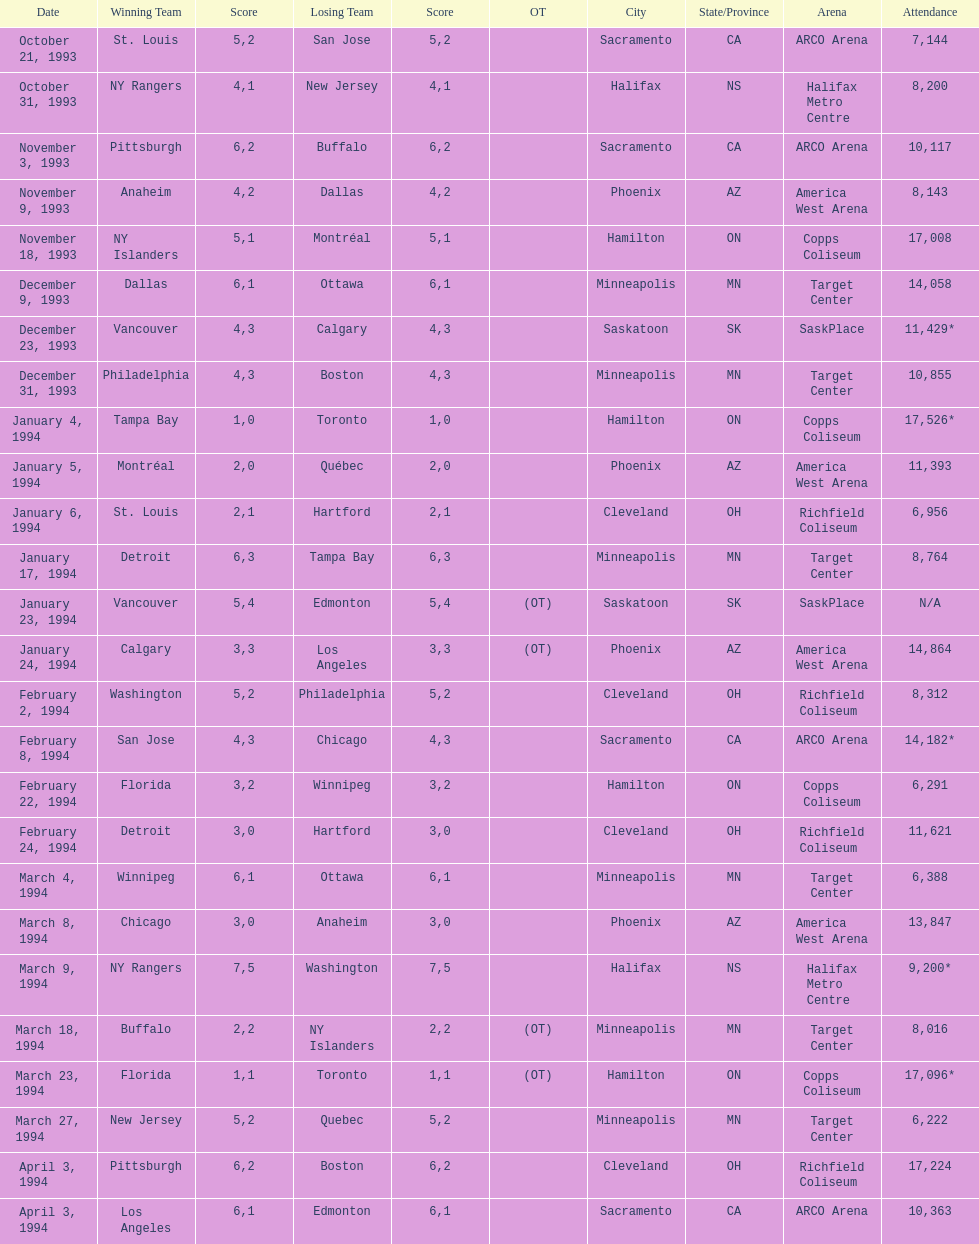Would you be able to parse every entry in this table? {'header': ['Date', 'Winning Team', 'Score', 'Losing Team', 'Score', 'OT', 'City', 'State/Province', 'Arena', 'Attendance'], 'rows': [['October 21, 1993', 'St. Louis', '5', 'San Jose', '2', '', 'Sacramento', 'CA', 'ARCO Arena', '7,144'], ['October 31, 1993', 'NY Rangers', '4', 'New Jersey', '1', '', 'Halifax', 'NS', 'Halifax Metro Centre', '8,200'], ['November 3, 1993', 'Pittsburgh', '6', 'Buffalo', '2', '', 'Sacramento', 'CA', 'ARCO Arena', '10,117'], ['November 9, 1993', 'Anaheim', '4', 'Dallas', '2', '', 'Phoenix', 'AZ', 'America West Arena', '8,143'], ['November 18, 1993', 'NY Islanders', '5', 'Montréal', '1', '', 'Hamilton', 'ON', 'Copps Coliseum', '17,008'], ['December 9, 1993', 'Dallas', '6', 'Ottawa', '1', '', 'Minneapolis', 'MN', 'Target Center', '14,058'], ['December 23, 1993', 'Vancouver', '4', 'Calgary', '3', '', 'Saskatoon', 'SK', 'SaskPlace', '11,429*'], ['December 31, 1993', 'Philadelphia', '4', 'Boston', '3', '', 'Minneapolis', 'MN', 'Target Center', '10,855'], ['January 4, 1994', 'Tampa Bay', '1', 'Toronto', '0', '', 'Hamilton', 'ON', 'Copps Coliseum', '17,526*'], ['January 5, 1994', 'Montréal', '2', 'Québec', '0', '', 'Phoenix', 'AZ', 'America West Arena', '11,393'], ['January 6, 1994', 'St. Louis', '2', 'Hartford', '1', '', 'Cleveland', 'OH', 'Richfield Coliseum', '6,956'], ['January 17, 1994', 'Detroit', '6', 'Tampa Bay', '3', '', 'Minneapolis', 'MN', 'Target Center', '8,764'], ['January 23, 1994', 'Vancouver', '5', 'Edmonton', '4', '(OT)', 'Saskatoon', 'SK', 'SaskPlace', 'N/A'], ['January 24, 1994', 'Calgary', '3', 'Los Angeles', '3', '(OT)', 'Phoenix', 'AZ', 'America West Arena', '14,864'], ['February 2, 1994', 'Washington', '5', 'Philadelphia', '2', '', 'Cleveland', 'OH', 'Richfield Coliseum', '8,312'], ['February 8, 1994', 'San Jose', '4', 'Chicago', '3', '', 'Sacramento', 'CA', 'ARCO Arena', '14,182*'], ['February 22, 1994', 'Florida', '3', 'Winnipeg', '2', '', 'Hamilton', 'ON', 'Copps Coliseum', '6,291'], ['February 24, 1994', 'Detroit', '3', 'Hartford', '0', '', 'Cleveland', 'OH', 'Richfield Coliseum', '11,621'], ['March 4, 1994', 'Winnipeg', '6', 'Ottawa', '1', '', 'Minneapolis', 'MN', 'Target Center', '6,388'], ['March 8, 1994', 'Chicago', '3', 'Anaheim', '0', '', 'Phoenix', 'AZ', 'America West Arena', '13,847'], ['March 9, 1994', 'NY Rangers', '7', 'Washington', '5', '', 'Halifax', 'NS', 'Halifax Metro Centre', '9,200*'], ['March 18, 1994', 'Buffalo', '2', 'NY Islanders', '2', '(OT)', 'Minneapolis', 'MN', 'Target Center', '8,016'], ['March 23, 1994', 'Florida', '1', 'Toronto', '1', '(OT)', 'Hamilton', 'ON', 'Copps Coliseum', '17,096*'], ['March 27, 1994', 'New Jersey', '5', 'Quebec', '2', '', 'Minneapolis', 'MN', 'Target Center', '6,222'], ['April 3, 1994', 'Pittsburgh', '6', 'Boston', '2', '', 'Cleveland', 'OH', 'Richfield Coliseum', '17,224'], ['April 3, 1994', 'Los Angeles', '6', 'Edmonton', '1', '', 'Sacramento', 'CA', 'ARCO Arena', '10,363']]} What is the difference in attendance between the november 18, 1993 games and the november 9th game? 8865. 